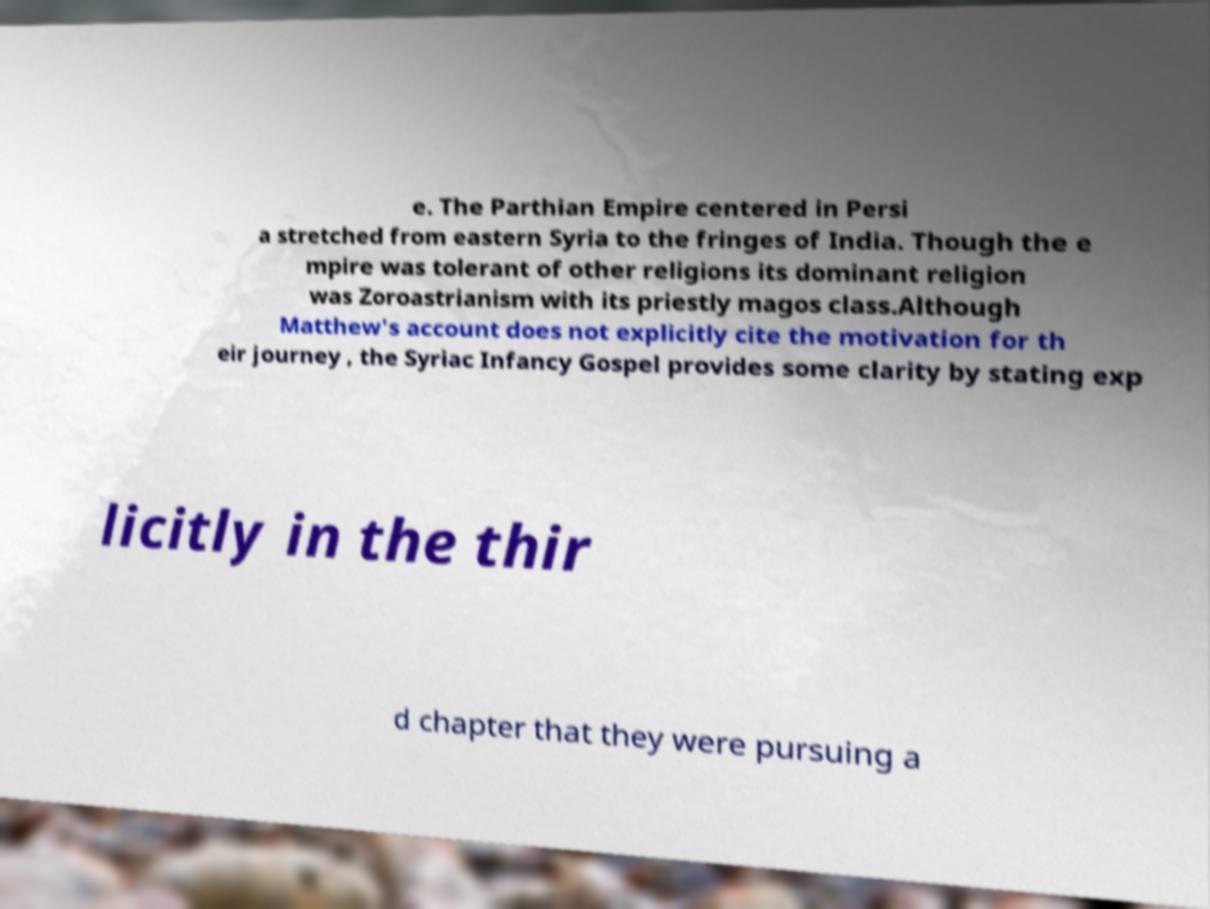Please read and relay the text visible in this image. What does it say? e. The Parthian Empire centered in Persi a stretched from eastern Syria to the fringes of India. Though the e mpire was tolerant of other religions its dominant religion was Zoroastrianism with its priestly magos class.Although Matthew's account does not explicitly cite the motivation for th eir journey , the Syriac Infancy Gospel provides some clarity by stating exp licitly in the thir d chapter that they were pursuing a 